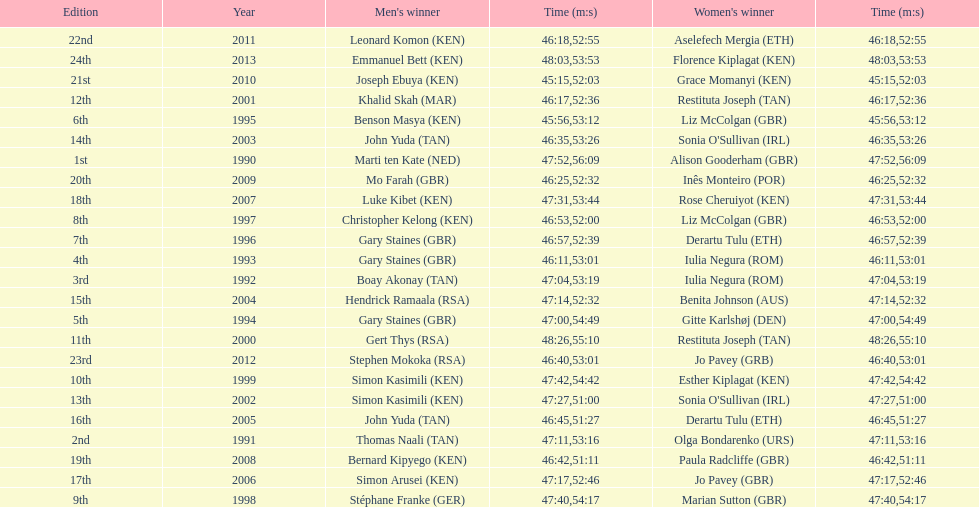The other women's winner with the same finish time as jo pavey in 2012 Iulia Negura. 